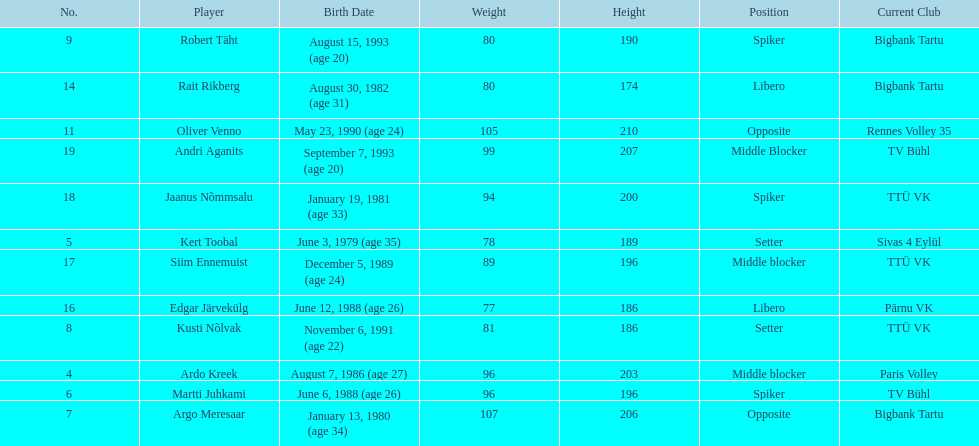What are the total number of players from france? 2. 